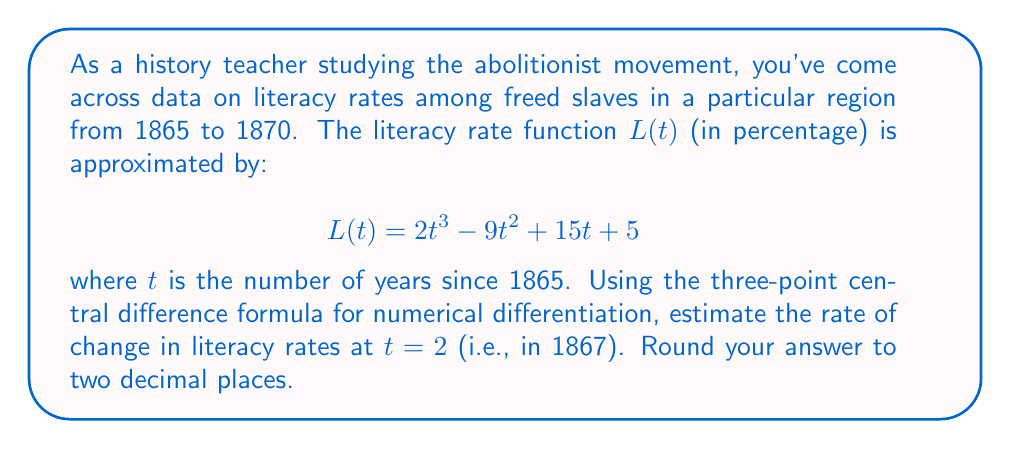Teach me how to tackle this problem. To solve this problem, we'll follow these steps:

1) The three-point central difference formula for the first derivative is:

   $$f'(x) \approx \frac{f(x+h) - f(x-h)}{2h}$$

   where $h$ is the step size.

2) In our case, we're estimating $L'(2)$, so $x = 2$. We'll use $h = 1$ for simplicity.

3) We need to calculate $L(1)$, $L(2)$, and $L(3)$:

   $L(1) = 2(1)^3 - 9(1)^2 + 15(1) + 5 = 2 - 9 + 15 + 5 = 13$
   
   $L(2) = 2(2)^3 - 9(2)^2 + 15(2) + 5 = 16 - 36 + 30 + 5 = 15$
   
   $L(3) = 2(3)^3 - 9(3)^2 + 15(3) + 5 = 54 - 81 + 45 + 5 = 23$

4) Now we can apply the formula:

   $$L'(2) \approx \frac{L(3) - L(1)}{2(1)} = \frac{23 - 13}{2} = 5$$

5) The rate of change is 5 percentage points per year.

6) Rounding to two decimal places: 5.00

This means the literacy rate among freed slaves was increasing by approximately 5 percentage points per year in 1867.
Answer: 5.00 percentage points per year 